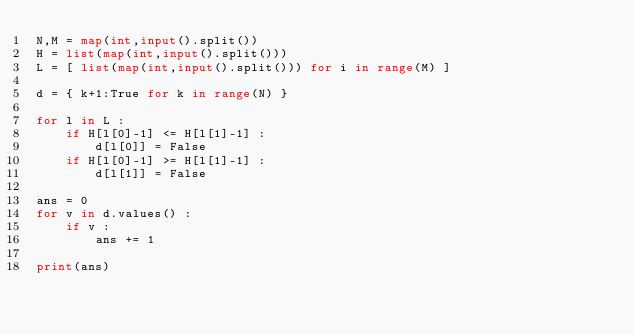<code> <loc_0><loc_0><loc_500><loc_500><_Python_>N,M = map(int,input().split())
H = list(map(int,input().split()))
L = [ list(map(int,input().split())) for i in range(M) ]

d = { k+1:True for k in range(N) }

for l in L :
    if H[l[0]-1] <= H[l[1]-1] :
        d[l[0]] = False
    if H[l[0]-1] >= H[l[1]-1] :
        d[l[1]] = False 
    
ans = 0
for v in d.values() :
    if v :
        ans += 1

print(ans)</code> 